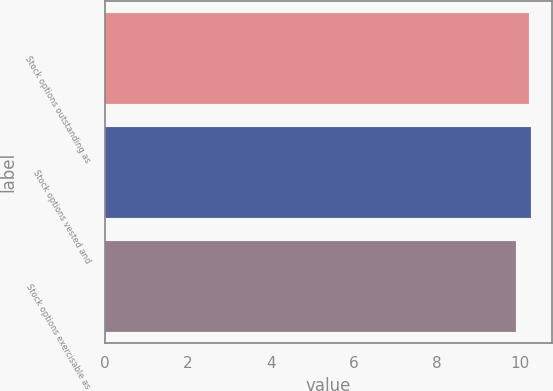Convert chart to OTSL. <chart><loc_0><loc_0><loc_500><loc_500><bar_chart><fcel>Stock options outstanding as<fcel>Stock options vested and<fcel>Stock options exercisable as<nl><fcel>10.24<fcel>10.27<fcel>9.92<nl></chart> 